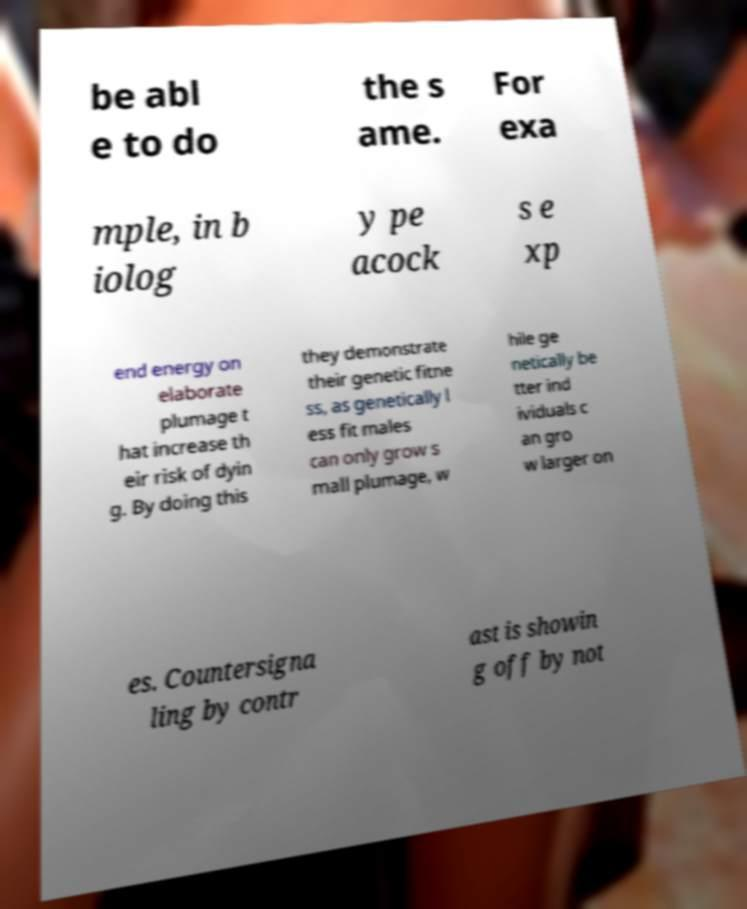Please read and relay the text visible in this image. What does it say? be abl e to do the s ame. For exa mple, in b iolog y pe acock s e xp end energy on elaborate plumage t hat increase th eir risk of dyin g. By doing this they demonstrate their genetic fitne ss, as genetically l ess fit males can only grow s mall plumage, w hile ge netically be tter ind ividuals c an gro w larger on es. Countersigna ling by contr ast is showin g off by not 